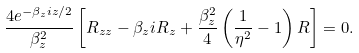Convert formula to latex. <formula><loc_0><loc_0><loc_500><loc_500>\frac { 4 e ^ { - \beta _ { z } i z / 2 } } { \beta _ { z } ^ { 2 } } \left [ R _ { z z } - \beta _ { z } i R _ { z } + \frac { \beta _ { z } ^ { 2 } } { 4 } \left ( \frac { 1 } { \eta ^ { 2 } } - 1 \right ) R \right ] = 0 .</formula> 